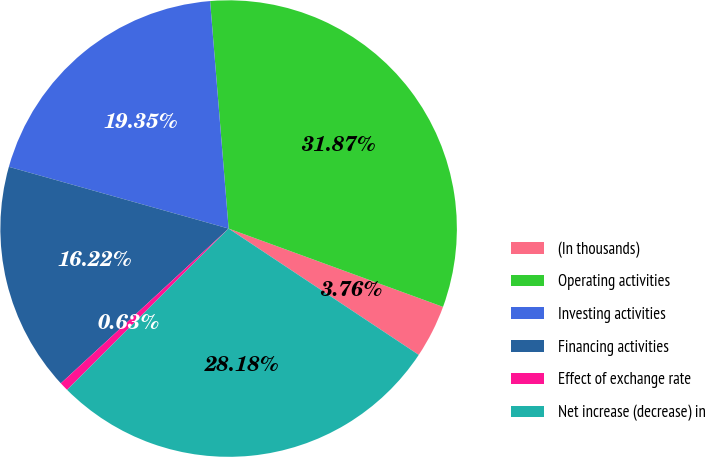<chart> <loc_0><loc_0><loc_500><loc_500><pie_chart><fcel>(In thousands)<fcel>Operating activities<fcel>Investing activities<fcel>Financing activities<fcel>Effect of exchange rate<fcel>Net increase (decrease) in<nl><fcel>3.76%<fcel>31.87%<fcel>19.35%<fcel>16.22%<fcel>0.63%<fcel>28.18%<nl></chart> 